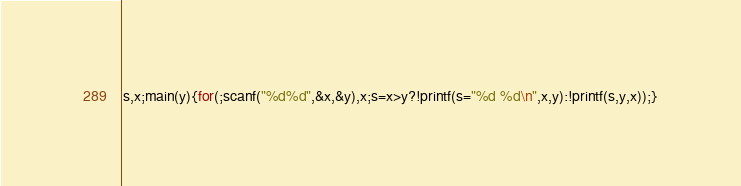Convert code to text. <code><loc_0><loc_0><loc_500><loc_500><_C_>s,x;main(y){for(;scanf("%d%d",&x,&y),x;s=x>y?!printf(s="%d %d\n",x,y):!printf(s,y,x));}</code> 